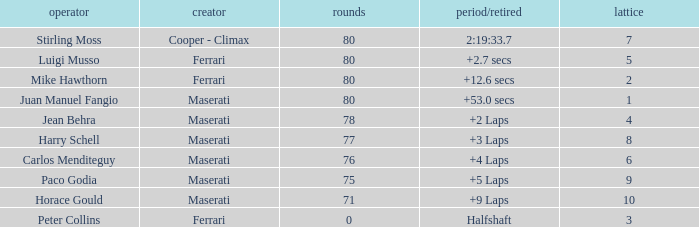What's the average Grid for a Maserati with less than 80 laps, and a Time/Retired of +2 laps? 4.0. 